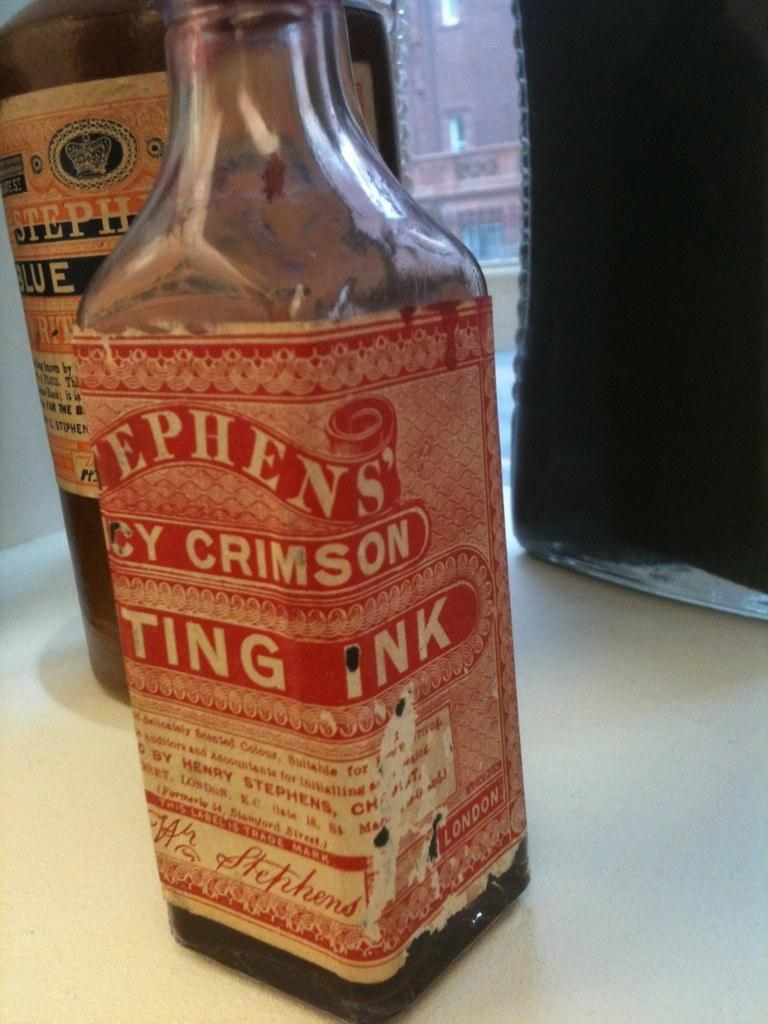<image>
Summarize the visual content of the image. Bottles of Stephen's ink sit near a window, the label on the crimson bottle slightly worn. 